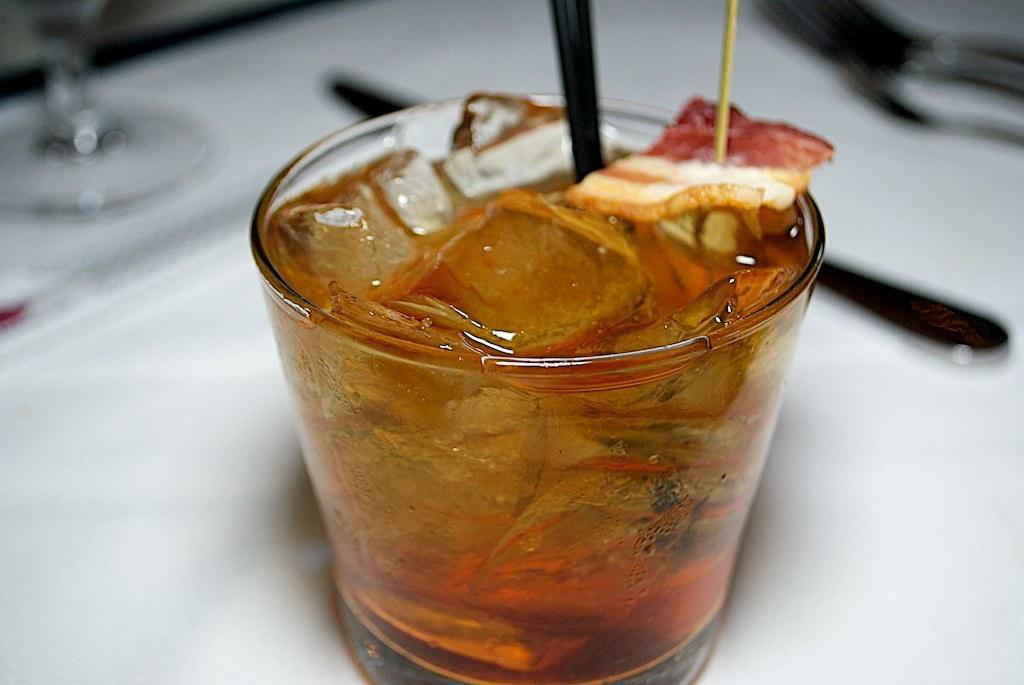What is on the white surface in the image? There is a glass of drink on a white surface. What is inside the glass? The glass contains ice and a drink. What type of utensil is in the glass? There is a black spoon in the glass. Can you describe the background of the image? The background is blurred. Are there any snakes visible in the park in the image? There is no park or snakes present in the image; it features a glass of drink on a white surface. 